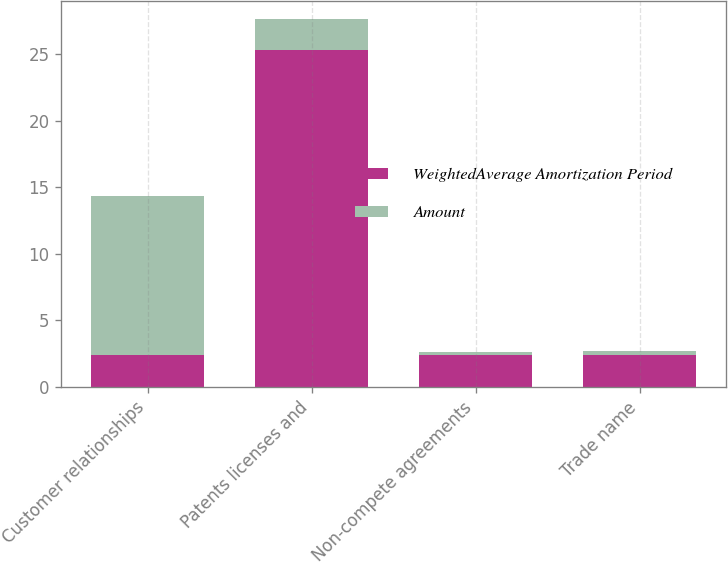<chart> <loc_0><loc_0><loc_500><loc_500><stacked_bar_chart><ecel><fcel>Customer relationships<fcel>Patents licenses and<fcel>Non-compete agreements<fcel>Trade name<nl><fcel>WeightedAverage Amortization Period<fcel>2.4<fcel>25.3<fcel>2.4<fcel>2.4<nl><fcel>Amount<fcel>11.9<fcel>2.3<fcel>0.2<fcel>0.3<nl></chart> 